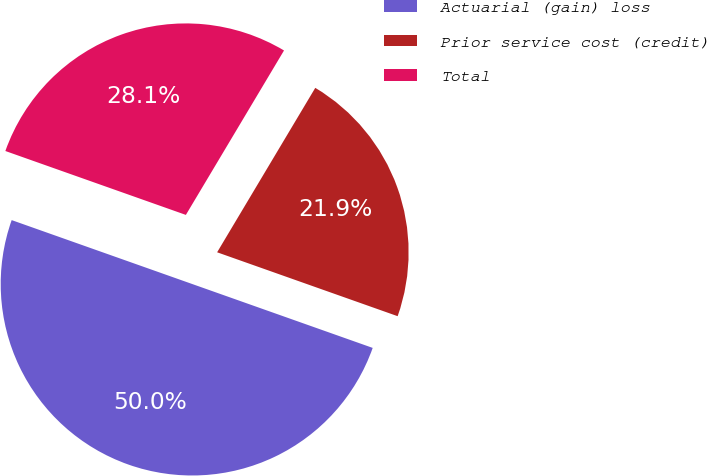Convert chart. <chart><loc_0><loc_0><loc_500><loc_500><pie_chart><fcel>Actuarial (gain) loss<fcel>Prior service cost (credit)<fcel>Total<nl><fcel>50.0%<fcel>21.85%<fcel>28.15%<nl></chart> 